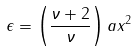Convert formula to latex. <formula><loc_0><loc_0><loc_500><loc_500>\epsilon = \left ( \frac { \nu + 2 } \nu \right ) a x ^ { 2 }</formula> 